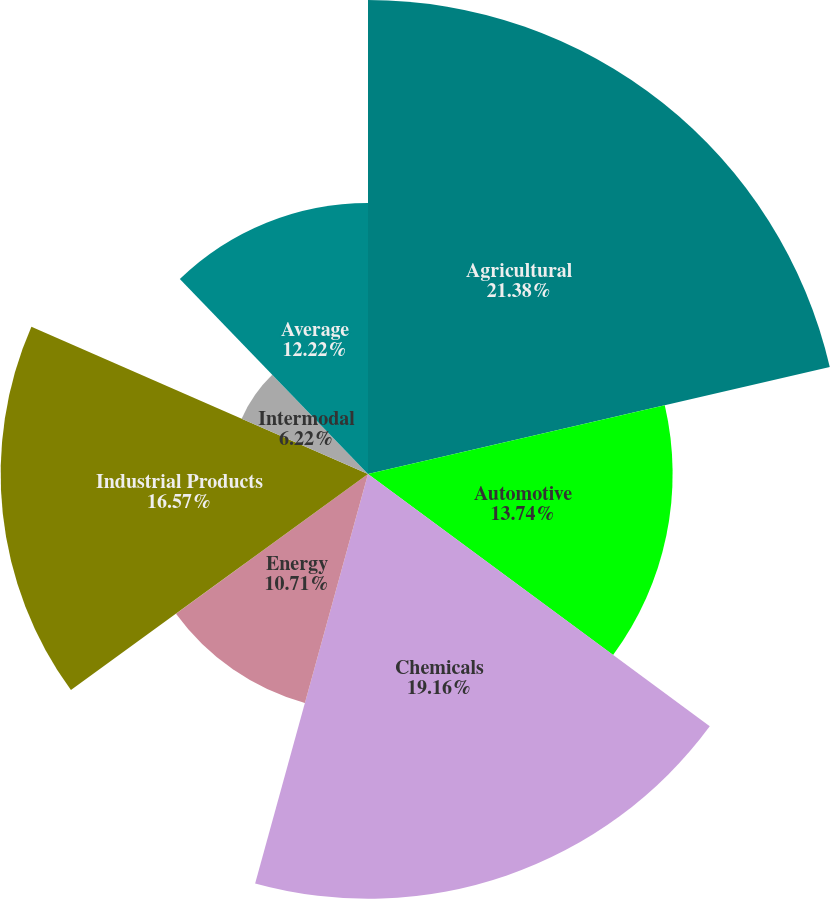Convert chart to OTSL. <chart><loc_0><loc_0><loc_500><loc_500><pie_chart><fcel>Agricultural<fcel>Automotive<fcel>Chemicals<fcel>Energy<fcel>Industrial Products<fcel>Intermodal<fcel>Average<nl><fcel>21.38%<fcel>13.74%<fcel>19.16%<fcel>10.71%<fcel>16.57%<fcel>6.22%<fcel>12.22%<nl></chart> 